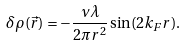<formula> <loc_0><loc_0><loc_500><loc_500>\delta \rho ( \vec { r } ) = - \frac { \nu \lambda } { 2 \pi r ^ { 2 } } \sin ( 2 k _ { F } r ) .</formula> 